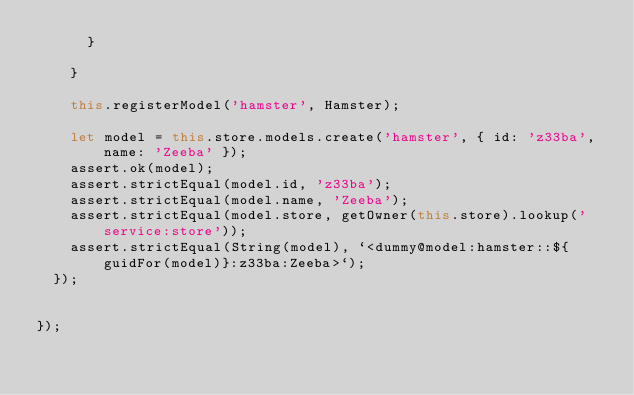<code> <loc_0><loc_0><loc_500><loc_500><_JavaScript_>      }

    }

    this.registerModel('hamster', Hamster);

    let model = this.store.models.create('hamster', { id: 'z33ba', name: 'Zeeba' });
    assert.ok(model);
    assert.strictEqual(model.id, 'z33ba');
    assert.strictEqual(model.name, 'Zeeba');
    assert.strictEqual(model.store, getOwner(this.store).lookup('service:store'));
    assert.strictEqual(String(model), `<dummy@model:hamster::${guidFor(model)}:z33ba:Zeeba>`);
  });


});
</code> 